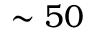Convert formula to latex. <formula><loc_0><loc_0><loc_500><loc_500>\sim 5 0</formula> 